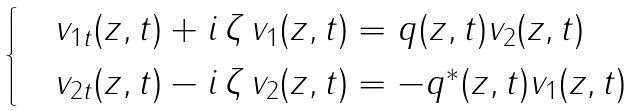<formula> <loc_0><loc_0><loc_500><loc_500>\begin{cases} & v _ { 1 t } ( z , t ) + i \, \zeta \, v _ { 1 } ( z , t ) = q ( z , t ) v _ { 2 } ( z , t ) \\ & v _ { 2 t } ( z , t ) - i \, \zeta \, v _ { 2 } ( z , t ) = - q ^ { * } ( z , t ) v _ { 1 } ( z , t ) \end{cases}</formula> 